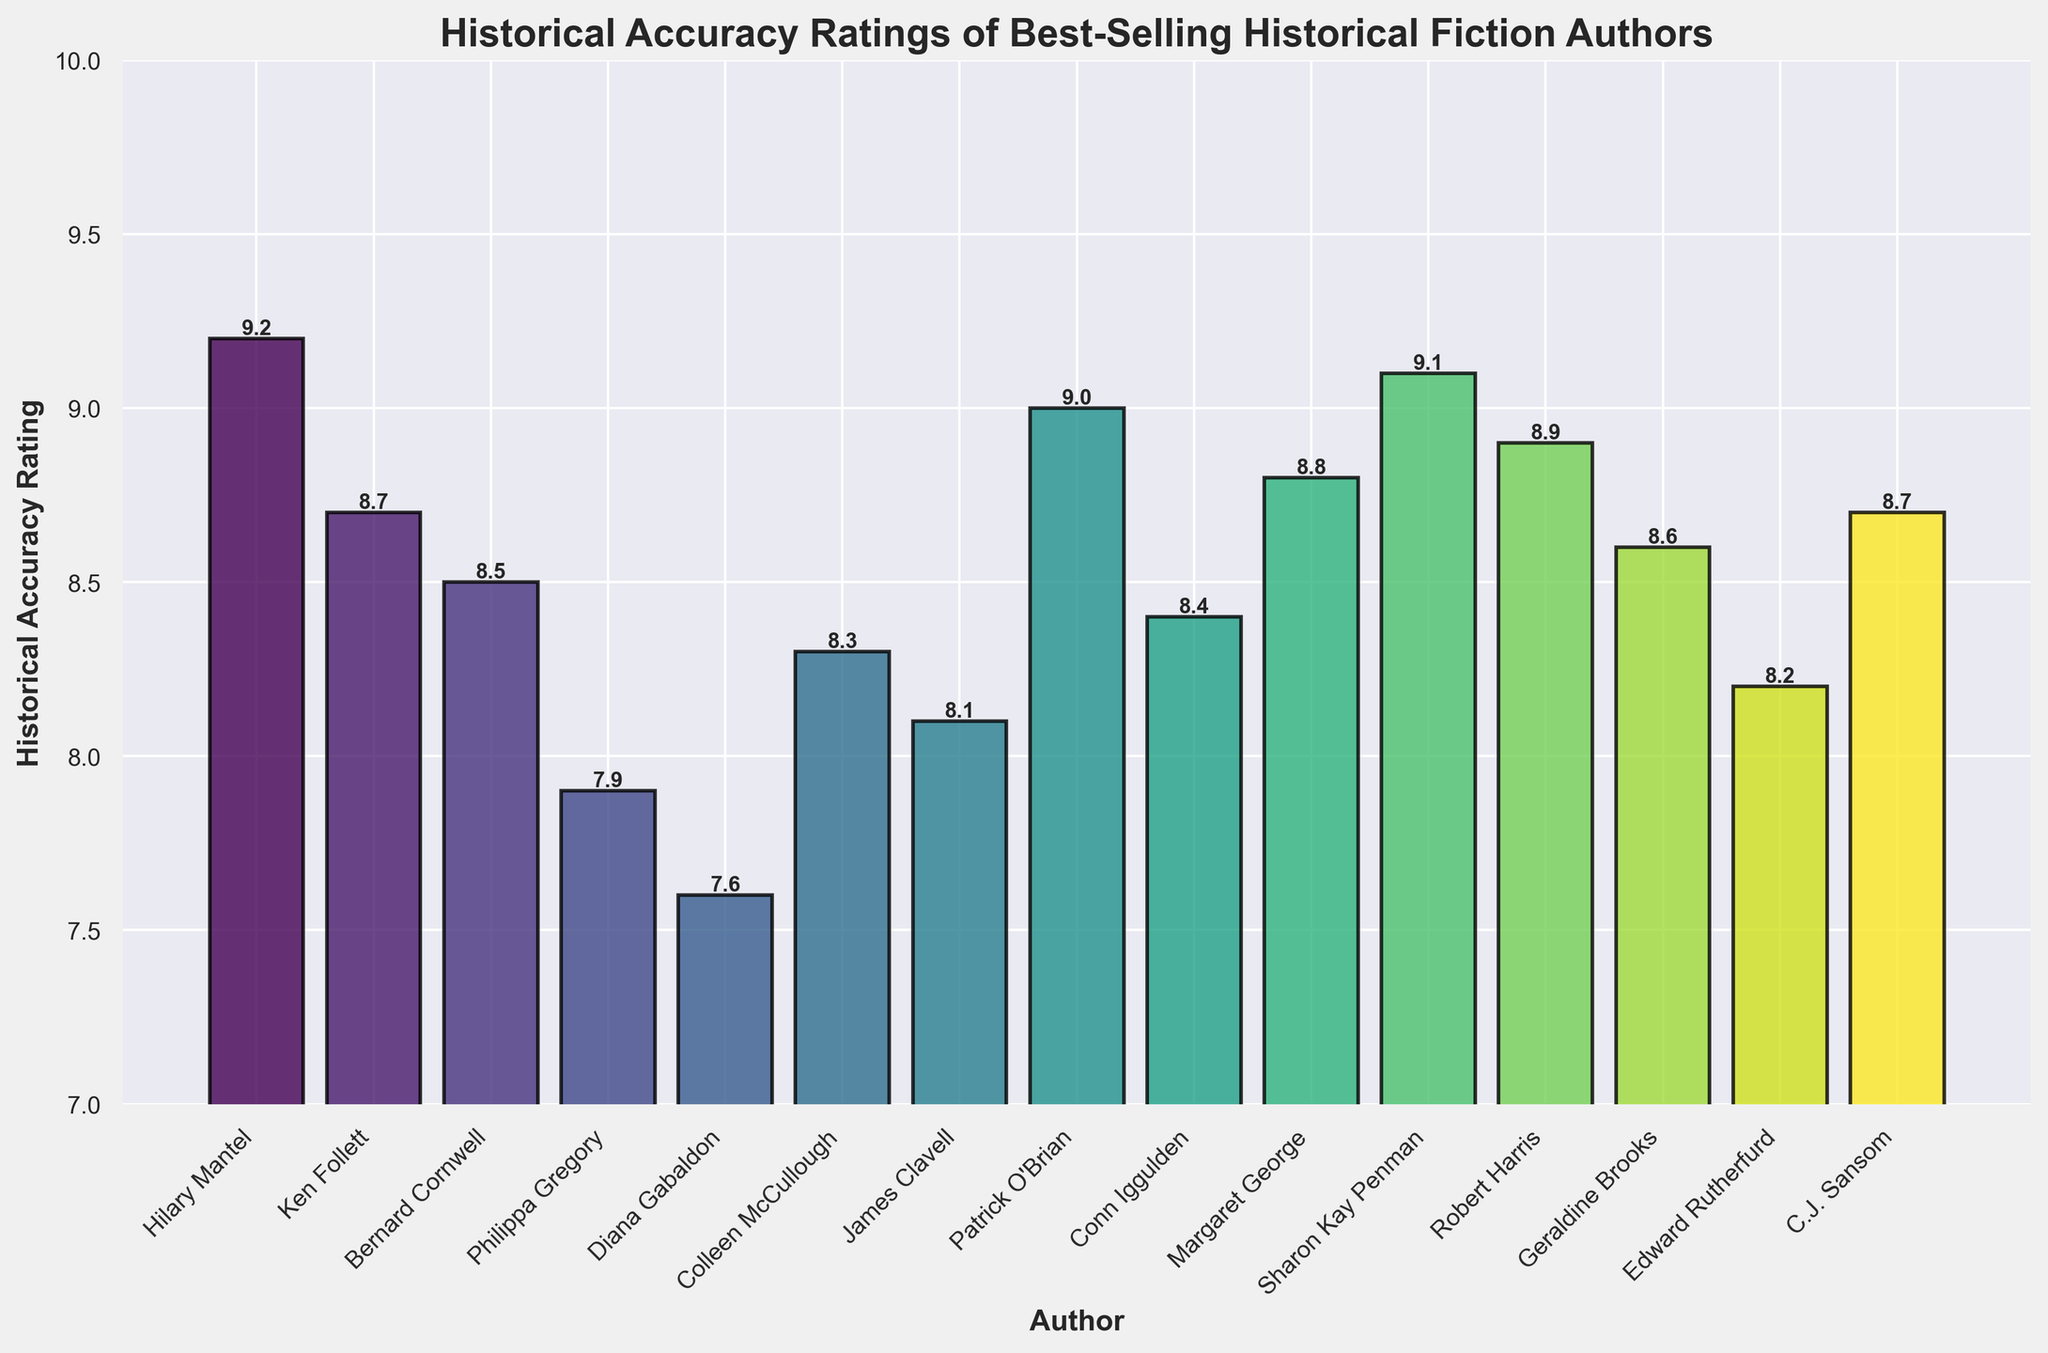Which author has the highest historical accuracy rating? The figure shows the historical accuracy ratings for various authors. The bar representing Hilary Mantel is the tallest, indicating the highest rating.
Answer: Hilary Mantel Which author has the lowest historical accuracy rating? The bar representing Diana Gabaldon is the shortest, indicating the lowest rating.
Answer: Diana Gabaldon What is the difference in the historical accuracy ratings between the highest and lowest rated authors? Hilary Mantel has the highest rating of 9.2, and Diana Gabaldon has the lowest rating of 7.6. The difference is calculated as 9.2 - 7.6.
Answer: 1.6 Which authors have a historical accuracy rating greater than 9.0? The authors with bars reaching above the 9.0 mark are Hilary Mantel (9.2), Patrick O'Brian (9.0), Sharon Kay Penman (9.1).
Answer: Hilary Mantel, Sharon Kay Penman What is the average historical accuracy rating of the authors with ratings between 8.0 and 9.0? Calculate the ratings for authors in this range: Ken Follett (8.7), Bernard Cornwell (8.5), Colleen McCullough (8.3), James Clavell (8.1), Conn Iggulden (8.4), Margaret George (8.8), Robert Harris (8.9), Geraldine Brooks (8.6), Edward Rutherfurd (8.2), and C.J. Sansom (8.7). Sum them and divide by the number of authors: (8.7 + 8.5 + 8.3 + 8.1 + 8.4 + 8.8 + 8.9 + 8.6 + 8.2 + 8.7) / 10.
Answer: 8.52 What is the median historical accuracy rating among all authors? List the ratings in ascending order: 7.6, 7.9, 8.1, 8.2, 8.3, 8.4, 8.5, 8.6, 8.7, 8.7, 8.8, 8.9, 9.0, 9.1, 9.2. The middle value (median) is the one at the 8th position: 8.6.
Answer: 8.6 How many authors have a historical accuracy rating of 8.7? Count the bars with a height corresponding to the 8.7 mark. Ken Follett and C.J. Sansom both have a rating of 8.7.
Answer: 2 Which author's bar is immediately to the left of Robert Harris's bar? Robert Harris has a rating of 8.9. The bar immediately to his left represents Sharon Kay Penman with a rating of 9.1.
Answer: Sharon Kay Penman Are there any authors with the same historical accuracy rating? If so, which ones? The bars for Ken Follett and C.J. Sansom both reach the same height, indicating they share the same rating of 8.7.
Answer: Ken Follett, C.J. Sansom Which author has a historical accuracy rating of exactly 8.5? The bar corresponding to Bernard Cornwell reaches the 8.5 mark.
Answer: Bernard Cornwell 